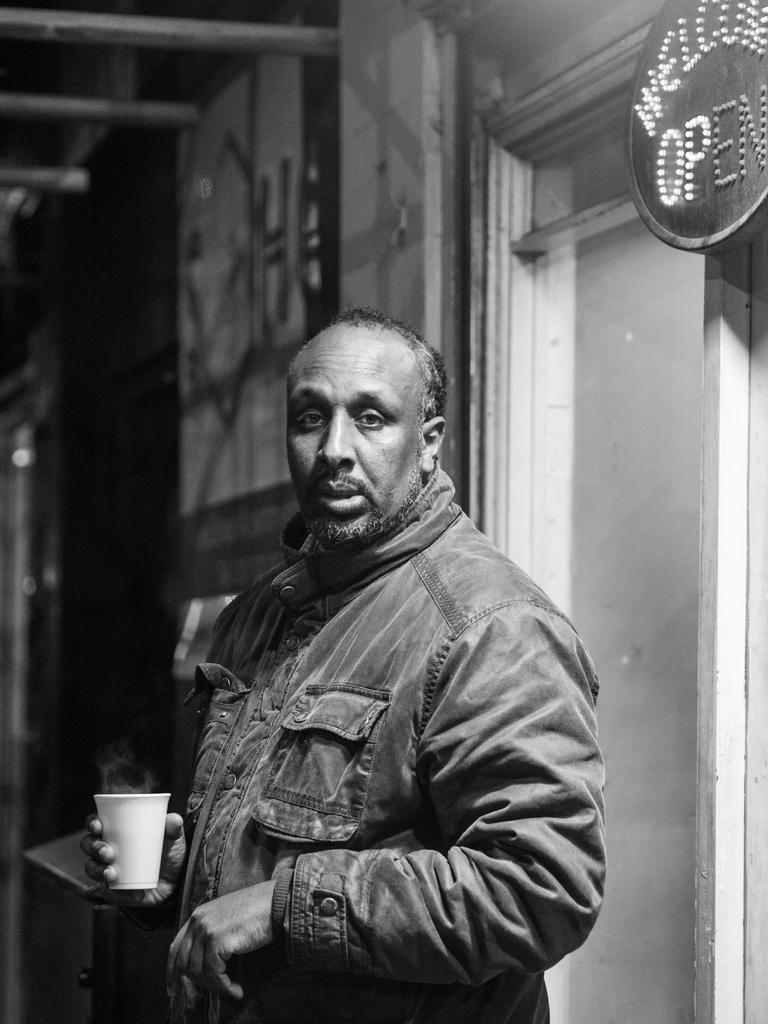Who is present in the image? There is a man in the image. What is the man wearing? The man is wearing a jacket. What is the man holding in the image? The man is holding a coffee cup. Where is the man standing in the image? The man is standing in front of a store. What type of skate is the man using to perform tricks in the image? There is no skate present in the image; the man is holding a coffee cup and standing in front of a store. 